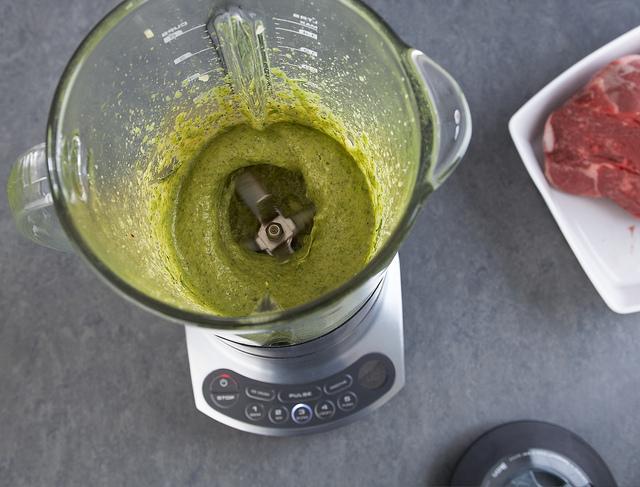What is used to make the green sauce?
Short answer required. Avocado. Why is the top off the blender?
Answer briefly. Been consumed. Will the green sauce be used on the meat?
Short answer required. Yes. How many buttons on the blender?
Keep it brief. 9. Is the meat raw?
Write a very short answer. Yes. 